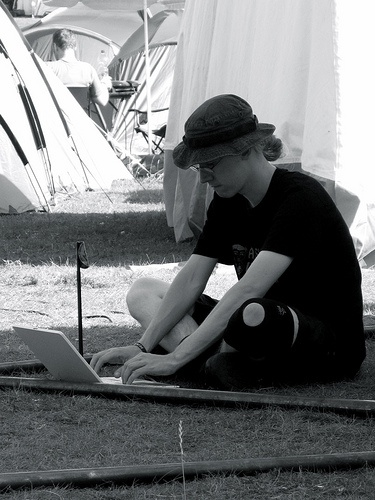Describe the objects in this image and their specific colors. I can see people in darkgray, black, gray, and white tones, laptop in darkgray, gray, black, and lightgray tones, people in darkgray, white, gray, and black tones, and chair in darkgray, gray, lightgray, and black tones in this image. 